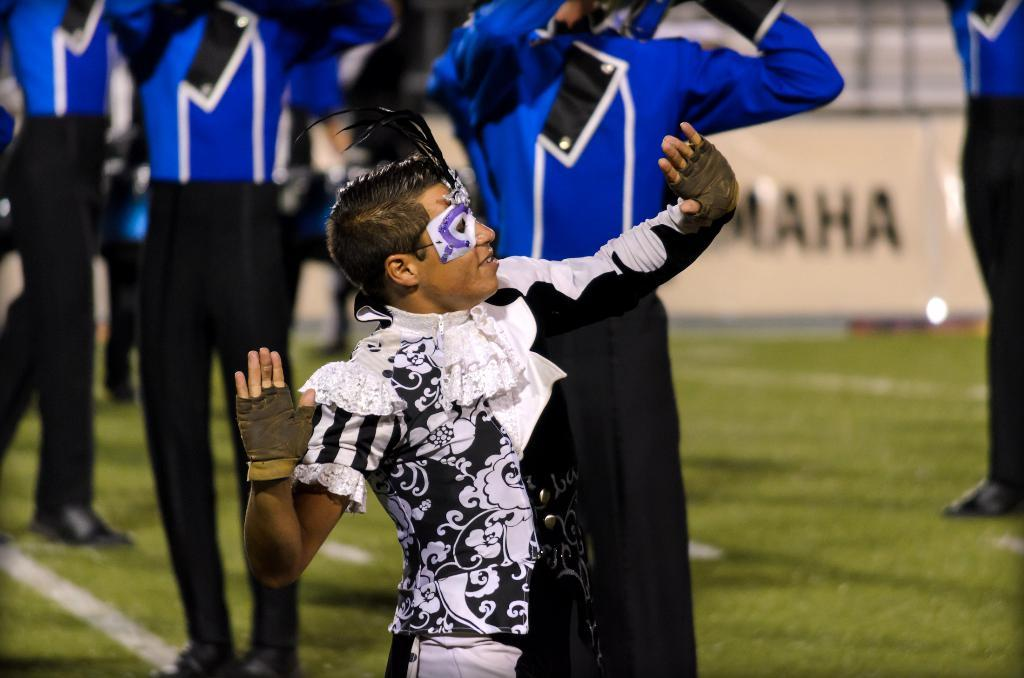<image>
Describe the image concisely. A person wearing fingerless gloves, mask and white and black outfit performs in front of others wearing blue and black on a field with MAHA written in the background. 